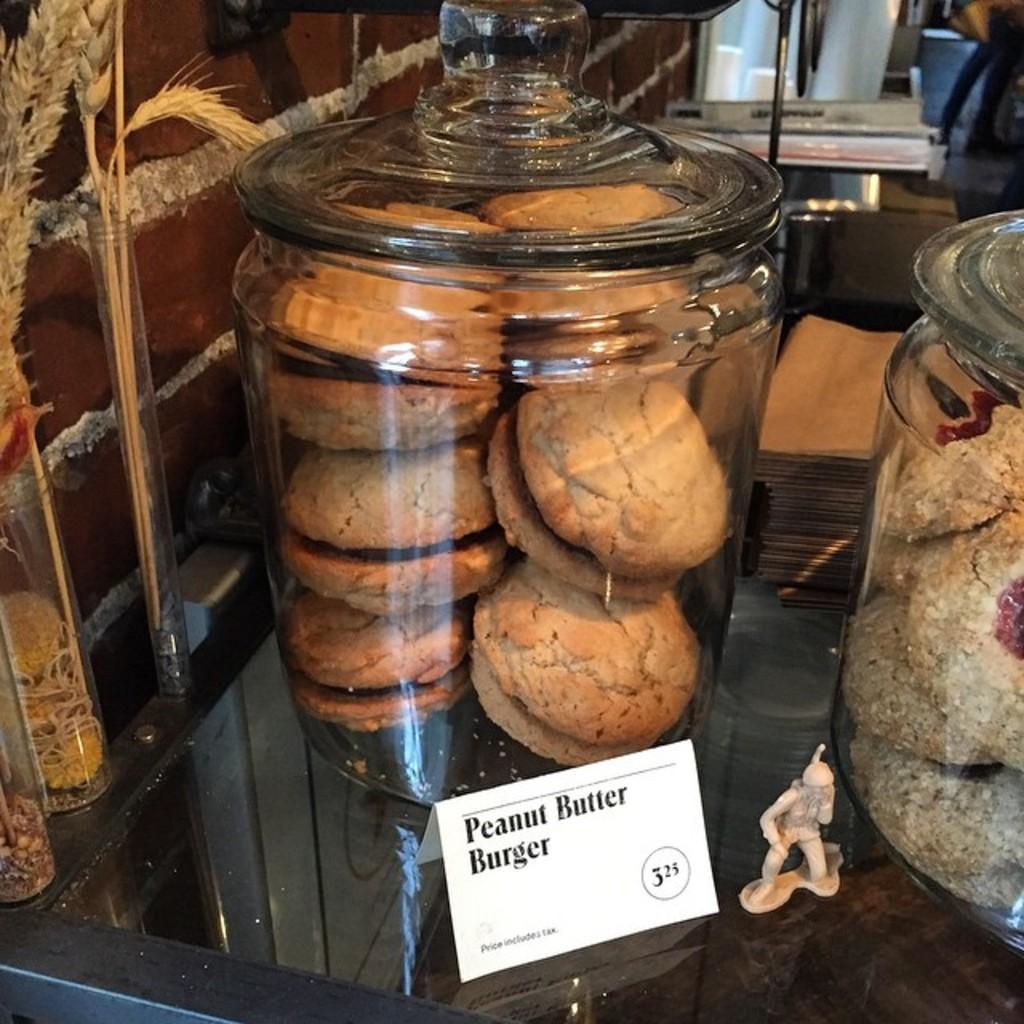Can you describe this image briefly? In this image, in the middle there is a jar inside that there are cookies. On the right there is a jar inside that there are cookies. At the bottom there is a poster, glass and a toy. In the background there are jars and a wall. 